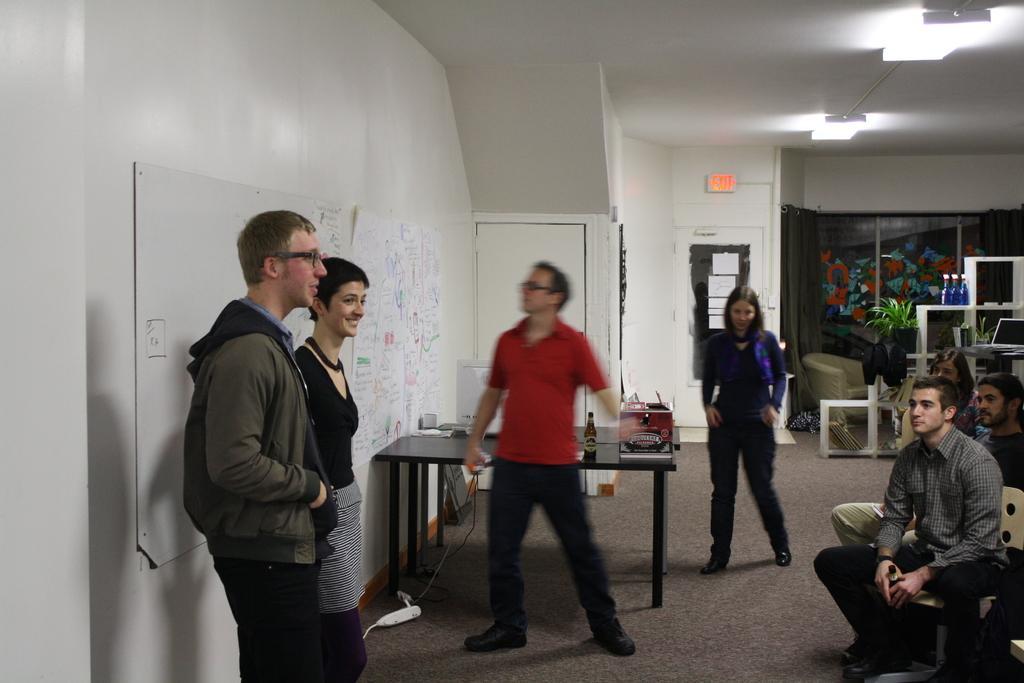Describe this image in one or two sentences. In this image there are so many people in which some of them are standing behind the boards and some sitting on chairs in a room, behind them there is a table with some things in it, also there is a notice board with some papers, and some plant pots on the wall. 